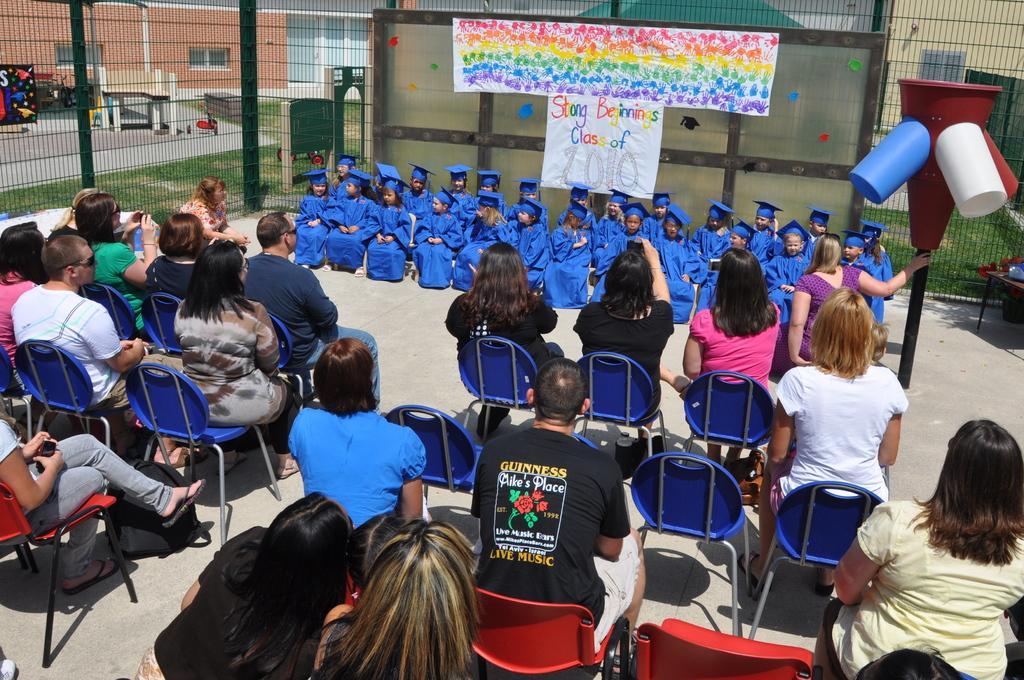How would you summarize this image in a sentence or two? In this image there are many people sitting on the chairs. In front of them there are kids sitting on the chairs. Behind them there are charts sticked on the wall. There is text on the wall. There is a fence around them. Outside the fence there's grass on the ground. In the background there are buildings. To the right there is a pole. 